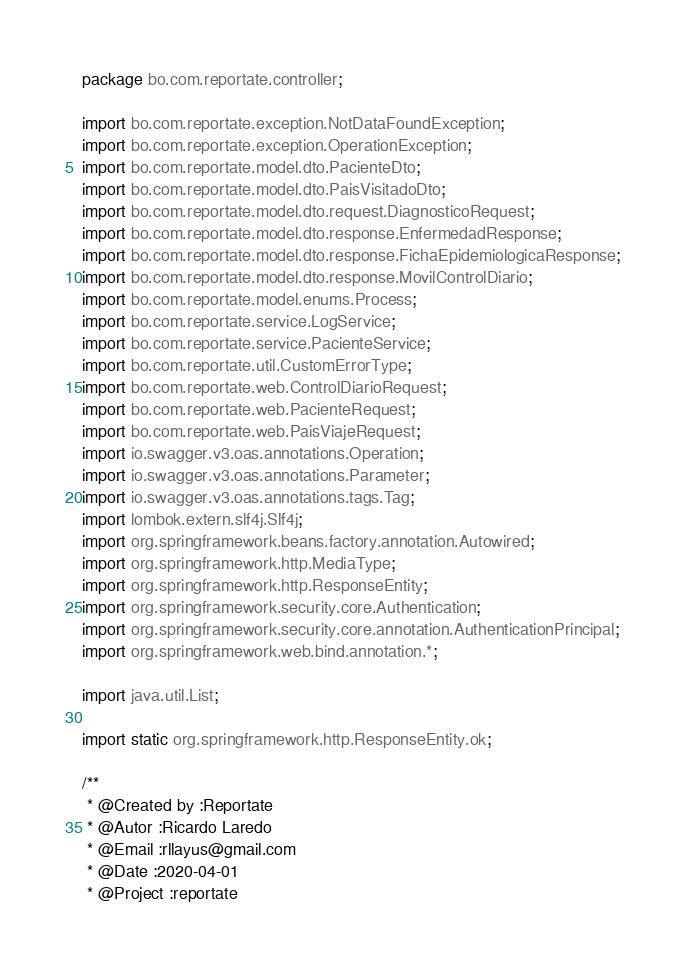<code> <loc_0><loc_0><loc_500><loc_500><_Java_>package bo.com.reportate.controller;

import bo.com.reportate.exception.NotDataFoundException;
import bo.com.reportate.exception.OperationException;
import bo.com.reportate.model.dto.PacienteDto;
import bo.com.reportate.model.dto.PaisVisitadoDto;
import bo.com.reportate.model.dto.request.DiagnosticoRequest;
import bo.com.reportate.model.dto.response.EnfermedadResponse;
import bo.com.reportate.model.dto.response.FichaEpidemiologicaResponse;
import bo.com.reportate.model.dto.response.MovilControlDiario;
import bo.com.reportate.model.enums.Process;
import bo.com.reportate.service.LogService;
import bo.com.reportate.service.PacienteService;
import bo.com.reportate.util.CustomErrorType;
import bo.com.reportate.web.ControlDiarioRequest;
import bo.com.reportate.web.PacienteRequest;
import bo.com.reportate.web.PaisViajeRequest;
import io.swagger.v3.oas.annotations.Operation;
import io.swagger.v3.oas.annotations.Parameter;
import io.swagger.v3.oas.annotations.tags.Tag;
import lombok.extern.slf4j.Slf4j;
import org.springframework.beans.factory.annotation.Autowired;
import org.springframework.http.MediaType;
import org.springframework.http.ResponseEntity;
import org.springframework.security.core.Authentication;
import org.springframework.security.core.annotation.AuthenticationPrincipal;
import org.springframework.web.bind.annotation.*;

import java.util.List;

import static org.springframework.http.ResponseEntity.ok;

/**
 * @Created by :Reportate
 * @Autor :Ricardo Laredo
 * @Email :rllayus@gmail.com
 * @Date :2020-04-01
 * @Project :reportate</code> 